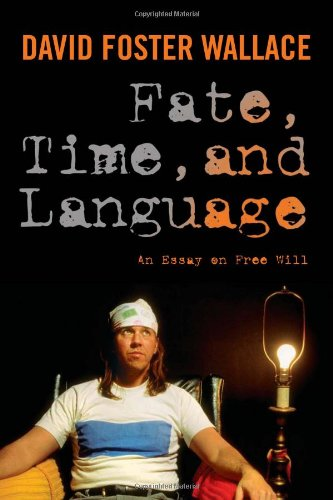Who wrote this book? The book was written by David Foster Wallace, a renowned author known for his complex narratives and deep exploration of philosophical themes. 